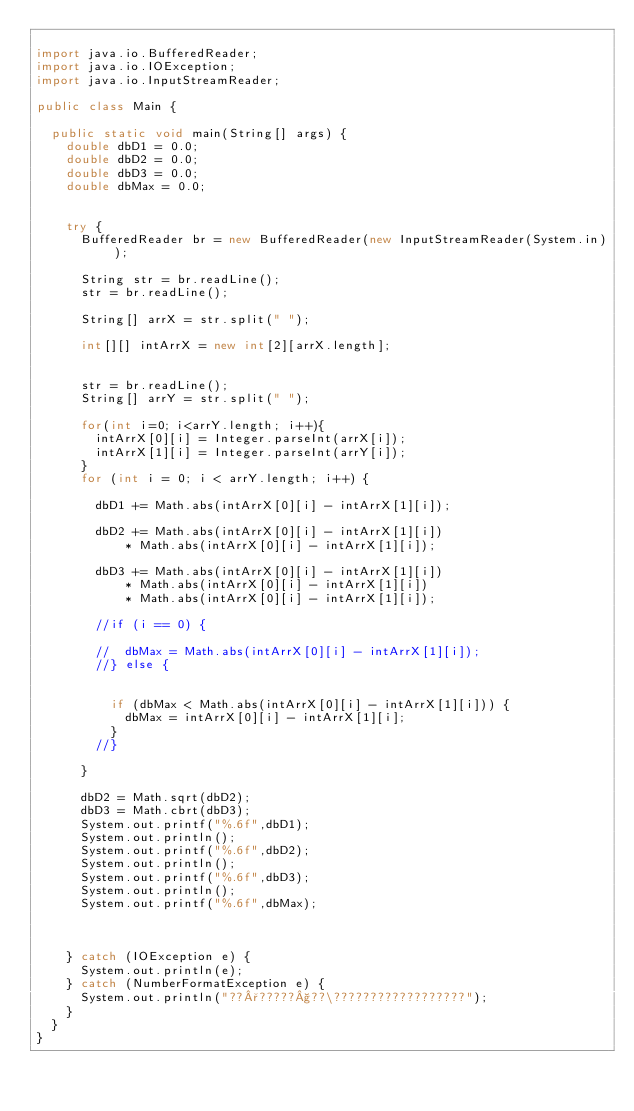<code> <loc_0><loc_0><loc_500><loc_500><_Java_>
import java.io.BufferedReader;
import java.io.IOException;
import java.io.InputStreamReader;

public class Main {

	public static void main(String[] args) {
		double dbD1 = 0.0;
		double dbD2 = 0.0;
		double dbD3 = 0.0;
		double dbMax = 0.0;


		try {
			BufferedReader br = new BufferedReader(new InputStreamReader(System.in));

			String str = br.readLine();
			str = br.readLine();

			String[] arrX = str.split(" ");

			int[][] intArrX = new int[2][arrX.length];


			str = br.readLine();
			String[] arrY = str.split(" ");

			for(int i=0; i<arrY.length; i++){
				intArrX[0][i] = Integer.parseInt(arrX[i]);
				intArrX[1][i] = Integer.parseInt(arrY[i]);
			}
			for (int i = 0; i < arrY.length; i++) {

				dbD1 += Math.abs(intArrX[0][i] - intArrX[1][i]);

				dbD2 += Math.abs(intArrX[0][i] - intArrX[1][i])
						* Math.abs(intArrX[0][i] - intArrX[1][i]);

				dbD3 += Math.abs(intArrX[0][i] - intArrX[1][i])
						* Math.abs(intArrX[0][i] - intArrX[1][i])
						* Math.abs(intArrX[0][i] - intArrX[1][i]);

				//if (i == 0) {

				//	dbMax = Math.abs(intArrX[0][i] - intArrX[1][i]);
				//} else {


					if (dbMax < Math.abs(intArrX[0][i] - intArrX[1][i])) {
						dbMax = intArrX[0][i] - intArrX[1][i];
					}
				//}

			}

			dbD2 = Math.sqrt(dbD2);
			dbD3 = Math.cbrt(dbD3);
			System.out.printf("%.6f",dbD1);
			System.out.println();
			System.out.printf("%.6f",dbD2);
			System.out.println();
			System.out.printf("%.6f",dbD3);
			System.out.println();
			System.out.printf("%.6f",dbMax);



		} catch (IOException e) {
			System.out.println(e);
		} catch (NumberFormatException e) {
			System.out.println("??°?????§??\??????????????????");
		}
	}
}</code> 